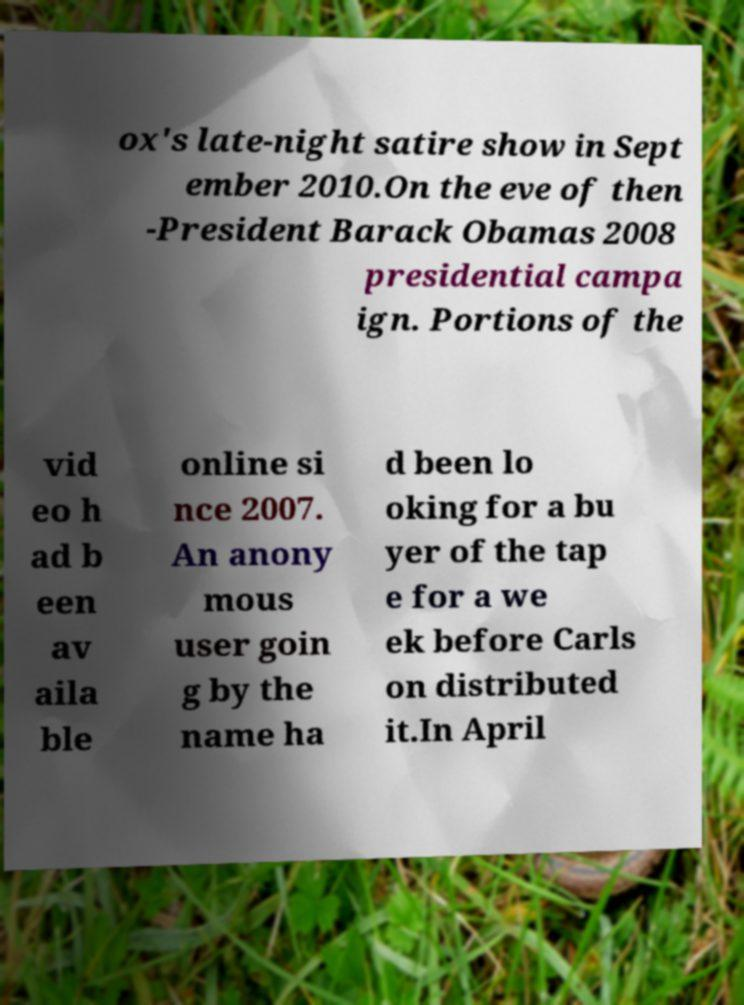Can you read and provide the text displayed in the image?This photo seems to have some interesting text. Can you extract and type it out for me? ox's late-night satire show in Sept ember 2010.On the eve of then -President Barack Obamas 2008 presidential campa ign. Portions of the vid eo h ad b een av aila ble online si nce 2007. An anony mous user goin g by the name ha d been lo oking for a bu yer of the tap e for a we ek before Carls on distributed it.In April 